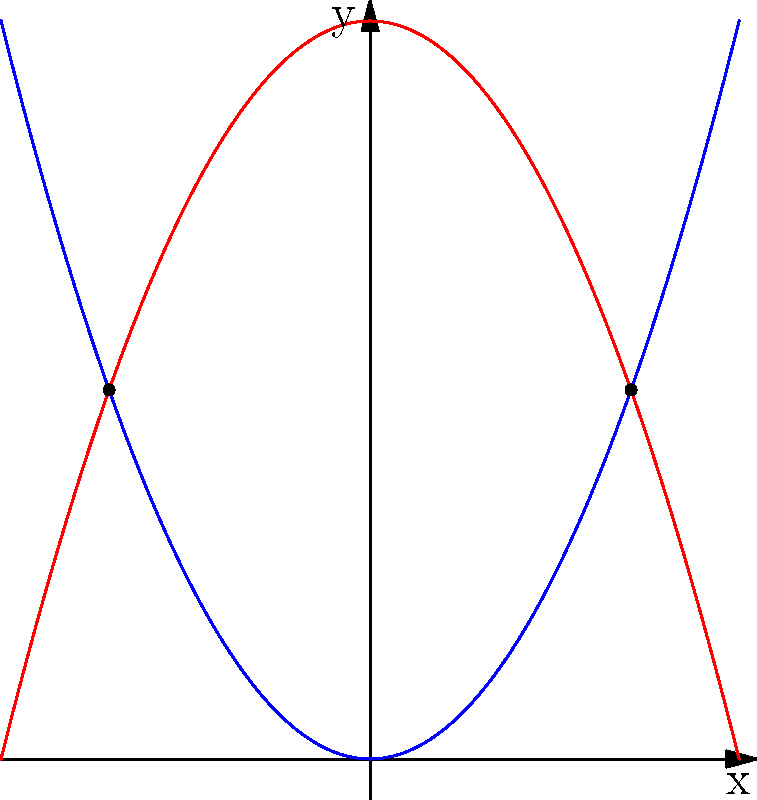Consider two parabolas representing the duality of existence in Zen philosophy: $y = x^2$ and $y = -x^2 + 4$. These curves intersect at two points, symbolizing the balance between opposing forces. Calculate the x-coordinates of these intersection points and interpret their significance in the context of artistic expression and Zen duality. To find the intersection points, we need to solve the equation:
$$x^2 = -x^2 + 4$$

Step 1: Rearrange the equation
$$2x^2 = 4$$

Step 2: Divide both sides by 2
$$x^2 = 2$$

Step 3: Take the square root of both sides
$$x = \pm\sqrt{2}$$

Step 4: Interpret the result
The x-coordinates of the intersection points are $\sqrt{2}$ and $-\sqrt{2}$.

In the context of Zen duality and artistic expression:
- The two intersection points represent the balance between opposing forces (yin and yang).
- The symmetry of the points ($\pm\sqrt{2}$) reflects the harmony in duality.
- The irrational nature of $\sqrt{2}$ symbolizes the transcendence of rational thought in Zen practice and artistic intuition.
- The parabolas' shapes (one opening upward, one downward) represent different perspectives or approaches to creativity, intersecting at points of balance.
Answer: $x = \pm\sqrt{2}$ 